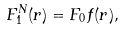Convert formula to latex. <formula><loc_0><loc_0><loc_500><loc_500>F _ { 1 } ^ { N } ( r ) = F _ { 0 } f ( r ) ,</formula> 